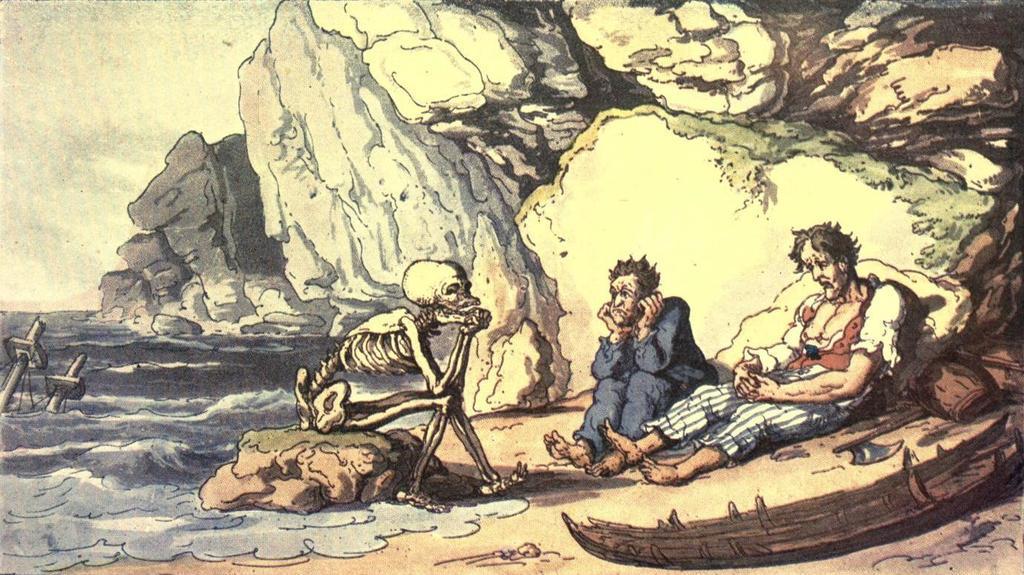Can you describe this image briefly? It is a painting. In this picture I can see hill, sky, water, boat, people, weapon, skeleton, rock, axe and objects.   